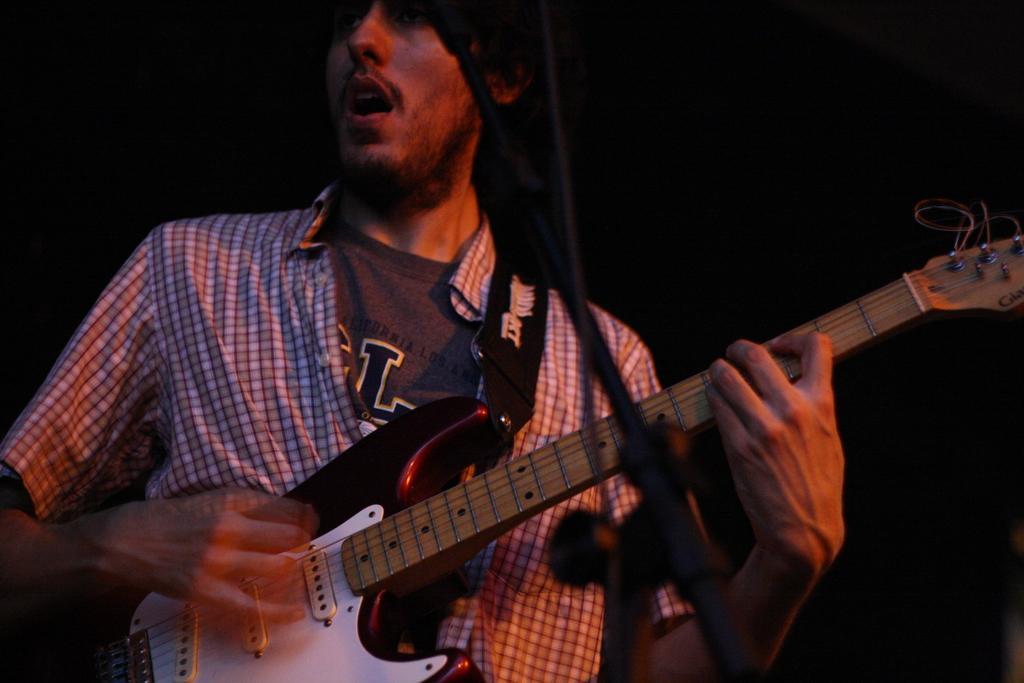In one or two sentences, can you explain what this image depicts? Here we can see a man holding a guitar in his hand. He is singing on a microphone. 